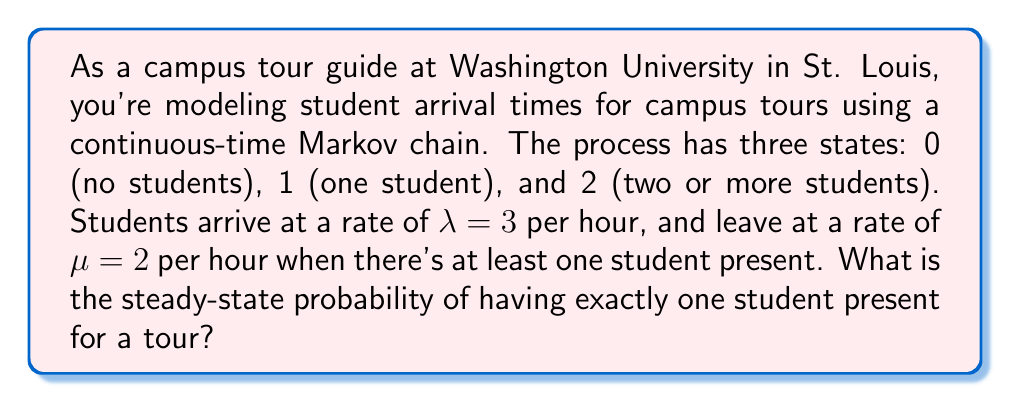Help me with this question. To solve this problem, we'll follow these steps:

1) First, let's define the transition rate matrix Q for this continuous-time Markov chain:

   $$Q = \begin{bmatrix}
   -\lambda & \lambda & 0 \\
   \mu & -(\lambda + \mu) & \lambda \\
   0 & \mu & -\mu
   \end{bmatrix} = \begin{bmatrix}
   -3 & 3 & 0 \\
   2 & -5 & 3 \\
   0 & 2 & -2
   \end{bmatrix}$$

2) The steady-state probabilities π = (π₀, π₁, π₂) satisfy the equation πQ = 0 and π₀ + π₁ + π₂ = 1.

3) This gives us the following system of equations:
   
   $$-3\pi_0 + 2\pi_1 = 0$$
   $$3\pi_0 - 5\pi_1 + 2\pi_2 = 0$$
   $$3\pi_1 - 2\pi_2 = 0$$
   $$\pi_0 + \pi_1 + \pi_2 = 1$$

4) From the third equation:
   $$\pi_2 = \frac{3}{2}\pi_1$$

5) Substituting this into the second equation:
   $$3\pi_0 - 5\pi_1 + 2(\frac{3}{2}\pi_1) = 0$$
   $$3\pi_0 - 2\pi_1 = 0$$
   $$\pi_0 = \frac{2}{3}\pi_1$$

6) Now we can express π₀ and π₂ in terms of π₁:
   $$\pi_0 = \frac{2}{3}\pi_1, \pi_2 = \frac{3}{2}\pi_1$$

7) Substituting these into the normalization condition:
   $$\frac{2}{3}\pi_1 + \pi_1 + \frac{3}{2}\pi_1 = 1$$
   $$(\frac{2}{3} + 1 + \frac{3}{2})\pi_1 = 1$$
   $$\frac{19}{6}\pi_1 = 1$$
   $$\pi_1 = \frac{6}{19}$$

Therefore, the steady-state probability of having exactly one student present for a tour is 6/19.
Answer: 6/19 